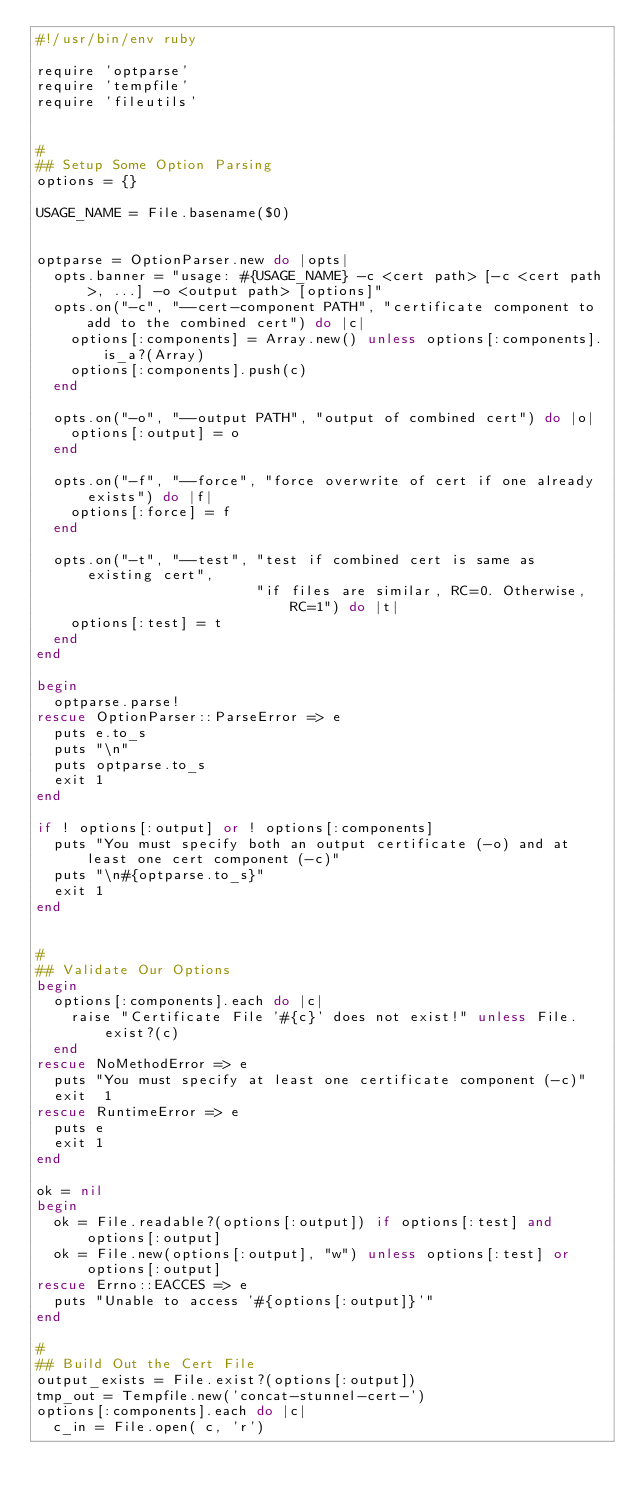<code> <loc_0><loc_0><loc_500><loc_500><_Ruby_>#!/usr/bin/env ruby

require 'optparse'
require 'tempfile'
require 'fileutils'


#
## Setup Some Option Parsing
options = {}

USAGE_NAME = File.basename($0)


optparse = OptionParser.new do |opts|
  opts.banner = "usage: #{USAGE_NAME} -c <cert path> [-c <cert path>, ...] -o <output path> [options]"
  opts.on("-c", "--cert-component PATH", "certificate component to add to the combined cert") do |c|
    options[:components] = Array.new() unless options[:components].is_a?(Array)
    options[:components].push(c)
  end

  opts.on("-o", "--output PATH", "output of combined cert") do |o|
    options[:output] = o
  end

  opts.on("-f", "--force", "force overwrite of cert if one already exists") do |f|
    options[:force] = f
  end

  opts.on("-t", "--test", "test if combined cert is same as existing cert",
                          "if files are similar, RC=0. Otherwise, RC=1") do |t|
    options[:test] = t
  end
end

begin
  optparse.parse!
rescue OptionParser::ParseError => e
  puts e.to_s
  puts "\n"
  puts optparse.to_s
  exit 1
end

if ! options[:output] or ! options[:components]
  puts "You must specify both an output certificate (-o) and at least one cert component (-c)"
  puts "\n#{optparse.to_s}"
  exit 1
end


#
## Validate Our Options
begin
  options[:components].each do |c|
    raise "Certificate File '#{c}' does not exist!" unless File.exist?(c)
  end
rescue NoMethodError => e
  puts "You must specify at least one certificate component (-c)"
  exit  1
rescue RuntimeError => e
  puts e
  exit 1
end

ok = nil
begin
  ok = File.readable?(options[:output]) if options[:test] and options[:output]
  ok = File.new(options[:output], "w") unless options[:test] or options[:output]
rescue Errno::EACCES => e
  puts "Unable to access '#{options[:output]}'"
end

#
## Build Out the Cert File
output_exists = File.exist?(options[:output])
tmp_out = Tempfile.new('concat-stunnel-cert-')
options[:components].each do |c|
  c_in = File.open( c, 'r')</code> 